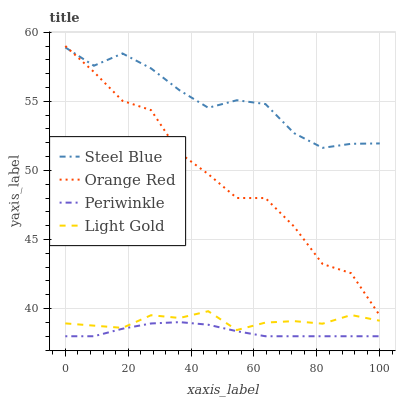Does Periwinkle have the minimum area under the curve?
Answer yes or no. Yes. Does Steel Blue have the maximum area under the curve?
Answer yes or no. Yes. Does Steel Blue have the minimum area under the curve?
Answer yes or no. No. Does Periwinkle have the maximum area under the curve?
Answer yes or no. No. Is Periwinkle the smoothest?
Answer yes or no. Yes. Is Orange Red the roughest?
Answer yes or no. Yes. Is Steel Blue the smoothest?
Answer yes or no. No. Is Steel Blue the roughest?
Answer yes or no. No. Does Steel Blue have the lowest value?
Answer yes or no. No. Does Orange Red have the highest value?
Answer yes or no. Yes. Does Steel Blue have the highest value?
Answer yes or no. No. Is Light Gold less than Steel Blue?
Answer yes or no. Yes. Is Orange Red greater than Periwinkle?
Answer yes or no. Yes. Does Orange Red intersect Steel Blue?
Answer yes or no. Yes. Is Orange Red less than Steel Blue?
Answer yes or no. No. Is Orange Red greater than Steel Blue?
Answer yes or no. No. Does Light Gold intersect Steel Blue?
Answer yes or no. No. 